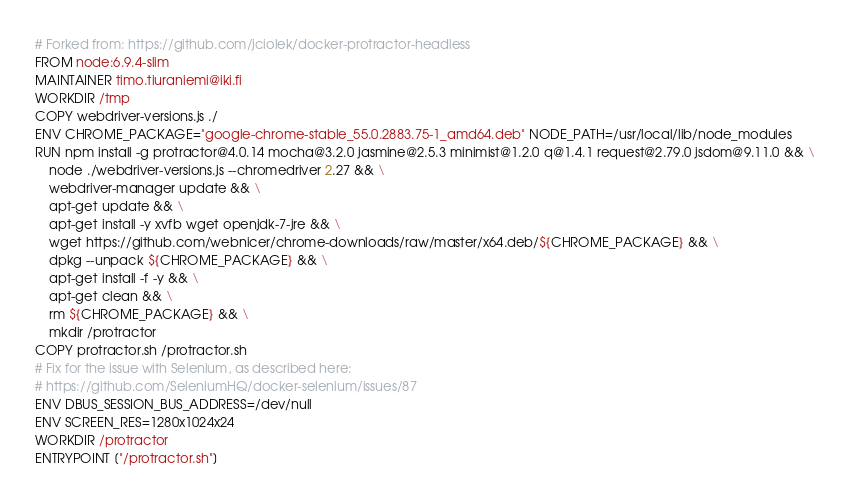Convert code to text. <code><loc_0><loc_0><loc_500><loc_500><_Dockerfile_># Forked from: https://github.com/jciolek/docker-protractor-headless
FROM node:6.9.4-slim
MAINTAINER timo.tiuraniemi@iki.fi
WORKDIR /tmp
COPY webdriver-versions.js ./
ENV CHROME_PACKAGE="google-chrome-stable_55.0.2883.75-1_amd64.deb" NODE_PATH=/usr/local/lib/node_modules
RUN npm install -g protractor@4.0.14 mocha@3.2.0 jasmine@2.5.3 minimist@1.2.0 q@1.4.1 request@2.79.0 jsdom@9.11.0 && \
    node ./webdriver-versions.js --chromedriver 2.27 && \
    webdriver-manager update && \
    apt-get update && \
    apt-get install -y xvfb wget openjdk-7-jre && \
    wget https://github.com/webnicer/chrome-downloads/raw/master/x64.deb/${CHROME_PACKAGE} && \
    dpkg --unpack ${CHROME_PACKAGE} && \
    apt-get install -f -y && \
    apt-get clean && \
    rm ${CHROME_PACKAGE} && \
    mkdir /protractor
COPY protractor.sh /protractor.sh
# Fix for the issue with Selenium, as described here:
# https://github.com/SeleniumHQ/docker-selenium/issues/87
ENV DBUS_SESSION_BUS_ADDRESS=/dev/null
ENV SCREEN_RES=1280x1024x24
WORKDIR /protractor
ENTRYPOINT ["/protractor.sh"]
</code> 